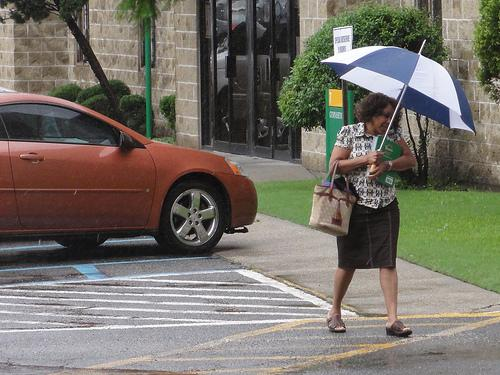Write a concise statement about the primary action taking place in the image. The primary action is a woman with an umbrella walking and carrying a green text book and a bag. Briefly mention the object that stands out most in the image and describe its color. The object that stands out most is a woman with curly hair wearing a brown dress. Provide a brief description of the image's primary focus. The primary focus is a woman walking under a blue and white striped umbrella, with a size of Width:170 and Height:170. Identify the main focal point of the image and give its dimensions. The main focal point is a woman walking under an umbrella, with dimensions Width:170 and Height:170. Pick the most noticeable element in the image and briefly describe its appearance. The most noticeable element is an open blue and white striped umbrella with a size of Width:160 and Height:160. Mention the main object in the image and describe its color and size. The main object is a woman with curly hair, wearing a brown dress, with a size of Width:88 and Height:88. Explain the central theme of the image in a simple sentence. A woman wearing a skirt, blouse, and sandals walks under an umbrella, carrying books and a brown handbag. Write a short sentence about the main activity happening in the image. A woman carrying books and a bag, with brown straps, is walking under an umbrella. Describe the central character in the image along with the objects they interact with. The central character is a woman with an umbrella, interacting with a green text book, a brown purse, and a bag. 